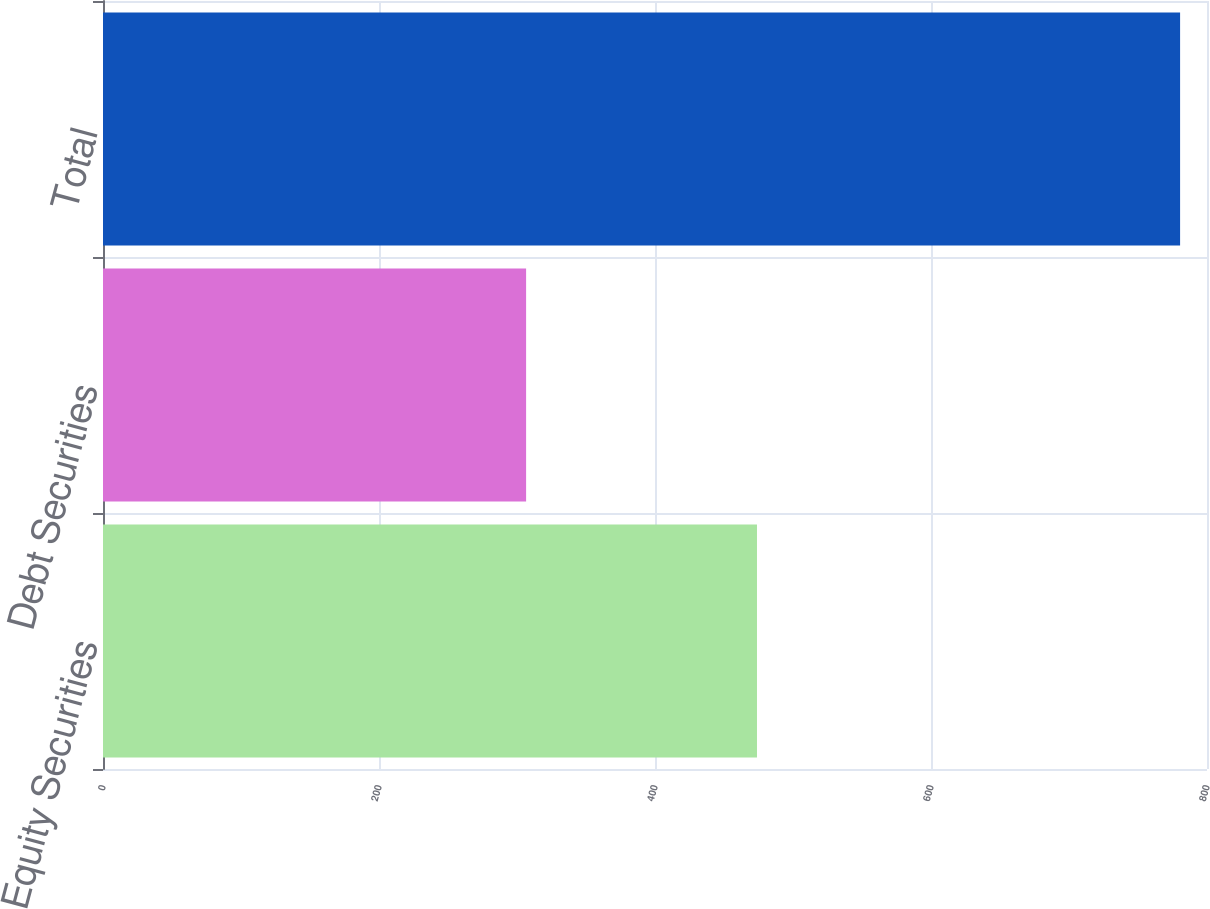Convert chart. <chart><loc_0><loc_0><loc_500><loc_500><bar_chart><fcel>Equity Securities<fcel>Debt Securities<fcel>Total<nl><fcel>473.9<fcel>306.6<fcel>780.5<nl></chart> 